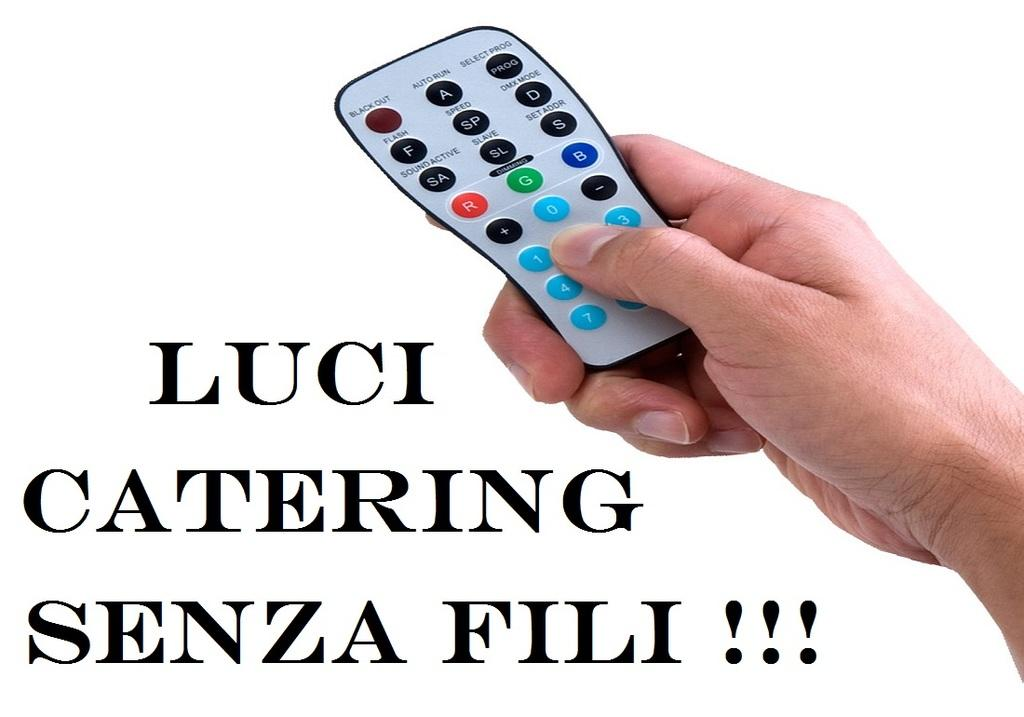<image>
Describe the image concisely. A hand holding a remote that says "Luci Catering Senza Fili!" 